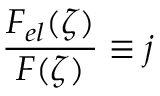Convert formula to latex. <formula><loc_0><loc_0><loc_500><loc_500>\frac { F _ { e l } ( \zeta ) } { F ( \zeta ) } \equiv j</formula> 